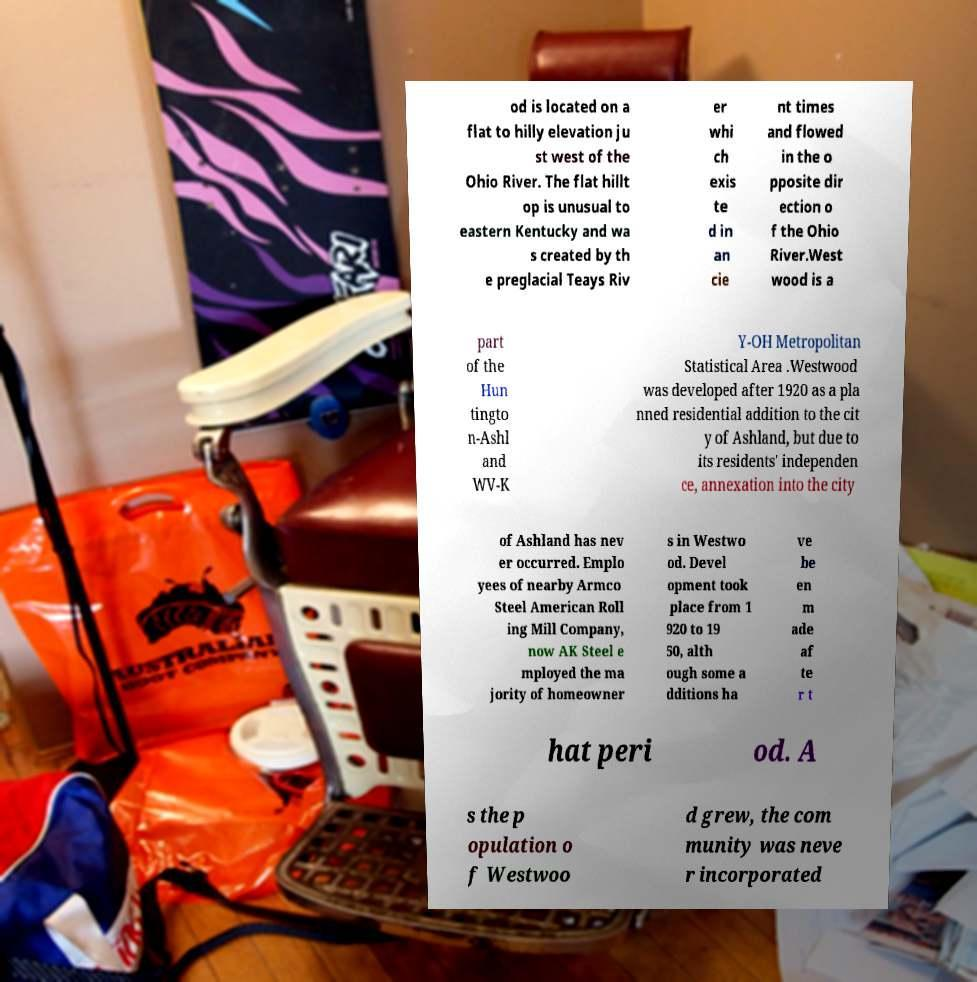Could you extract and type out the text from this image? od is located on a flat to hilly elevation ju st west of the Ohio River. The flat hillt op is unusual to eastern Kentucky and wa s created by th e preglacial Teays Riv er whi ch exis te d in an cie nt times and flowed in the o pposite dir ection o f the Ohio River.West wood is a part of the Hun tingto n-Ashl and WV-K Y-OH Metropolitan Statistical Area .Westwood was developed after 1920 as a pla nned residential addition to the cit y of Ashland, but due to its residents' independen ce, annexation into the city of Ashland has nev er occurred. Emplo yees of nearby Armco Steel American Roll ing Mill Company, now AK Steel e mployed the ma jority of homeowner s in Westwo od. Devel opment took place from 1 920 to 19 50, alth ough some a dditions ha ve be en m ade af te r t hat peri od. A s the p opulation o f Westwoo d grew, the com munity was neve r incorporated 